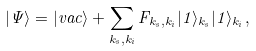Convert formula to latex. <formula><loc_0><loc_0><loc_500><loc_500>| \Psi \rangle = | v a c \rangle + \sum _ { k _ { s } , k _ { i } } F _ { k _ { s } , k _ { i } } | 1 \rangle _ { k _ { s } } | 1 \rangle _ { k _ { i } } ,</formula> 